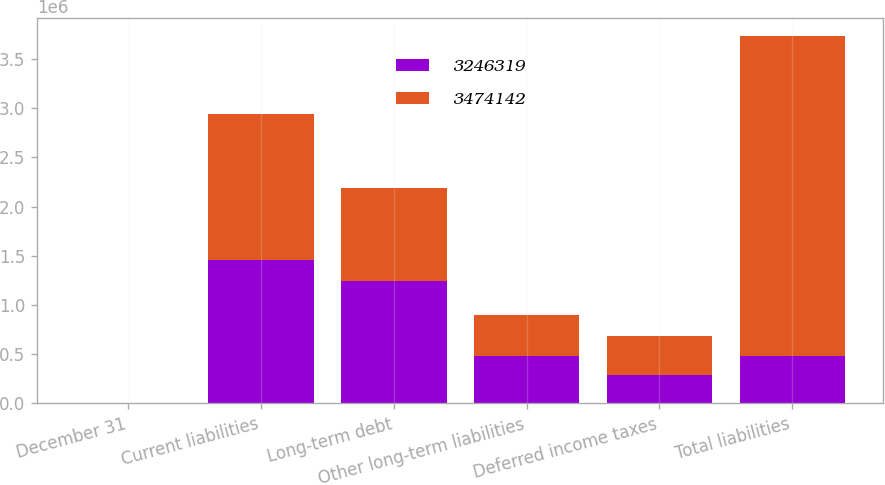Convert chart. <chart><loc_0><loc_0><loc_500><loc_500><stacked_bar_chart><ecel><fcel>December 31<fcel>Current liabilities<fcel>Long-term debt<fcel>Other long-term liabilities<fcel>Deferred income taxes<fcel>Total liabilities<nl><fcel>3.24632e+06<fcel>2006<fcel>1.45354e+06<fcel>1.24813e+06<fcel>486473<fcel>286003<fcel>486473<nl><fcel>3.47414e+06<fcel>2005<fcel>1.49038e+06<fcel>942755<fcel>412929<fcel>400253<fcel>3.24632e+06<nl></chart> 